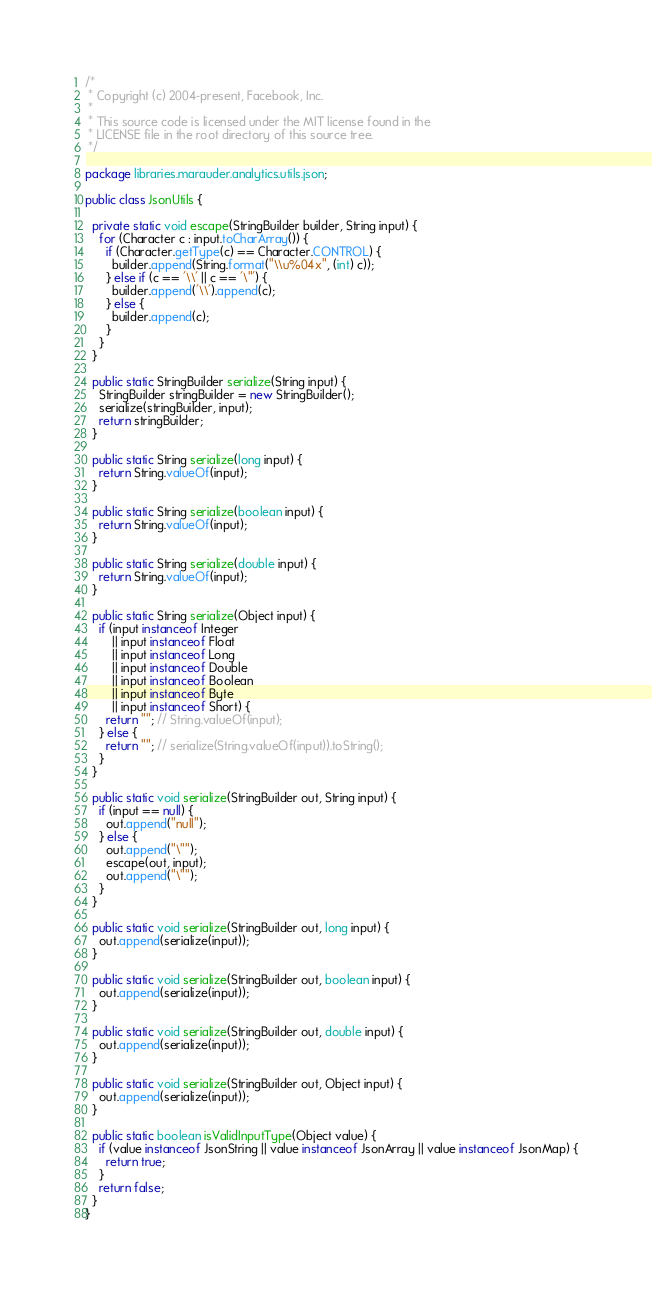<code> <loc_0><loc_0><loc_500><loc_500><_Java_>/*
 * Copyright (c) 2004-present, Facebook, Inc.
 *
 * This source code is licensed under the MIT license found in the
 * LICENSE file in the root directory of this source tree.
 */

package libraries.marauder.analytics.utils.json;

public class JsonUtils {

  private static void escape(StringBuilder builder, String input) {
    for (Character c : input.toCharArray()) {
      if (Character.getType(c) == Character.CONTROL) {
        builder.append(String.format("\\u%04x", (int) c));
      } else if (c == '\\' || c == '\"') {
        builder.append('\\').append(c);
      } else {
        builder.append(c);
      }
    }
  }

  public static StringBuilder serialize(String input) {
    StringBuilder stringBuilder = new StringBuilder();
    serialize(stringBuilder, input);
    return stringBuilder;
  }

  public static String serialize(long input) {
    return String.valueOf(input);
  }

  public static String serialize(boolean input) {
    return String.valueOf(input);
  }

  public static String serialize(double input) {
    return String.valueOf(input);
  }

  public static String serialize(Object input) {
    if (input instanceof Integer
        || input instanceof Float
        || input instanceof Long
        || input instanceof Double
        || input instanceof Boolean
        || input instanceof Byte
        || input instanceof Short) {
      return ""; // String.valueOf(input);
    } else {
      return ""; // serialize(String.valueOf(input)).toString();
    }
  }

  public static void serialize(StringBuilder out, String input) {
    if (input == null) {
      out.append("null");
    } else {
      out.append("\"");
      escape(out, input);
      out.append("\"");
    }
  }

  public static void serialize(StringBuilder out, long input) {
    out.append(serialize(input));
  }

  public static void serialize(StringBuilder out, boolean input) {
    out.append(serialize(input));
  }

  public static void serialize(StringBuilder out, double input) {
    out.append(serialize(input));
  }

  public static void serialize(StringBuilder out, Object input) {
    out.append(serialize(input));
  }

  public static boolean isValidInputType(Object value) {
    if (value instanceof JsonString || value instanceof JsonArray || value instanceof JsonMap) {
      return true;
    }
    return false;
  }
}
</code> 